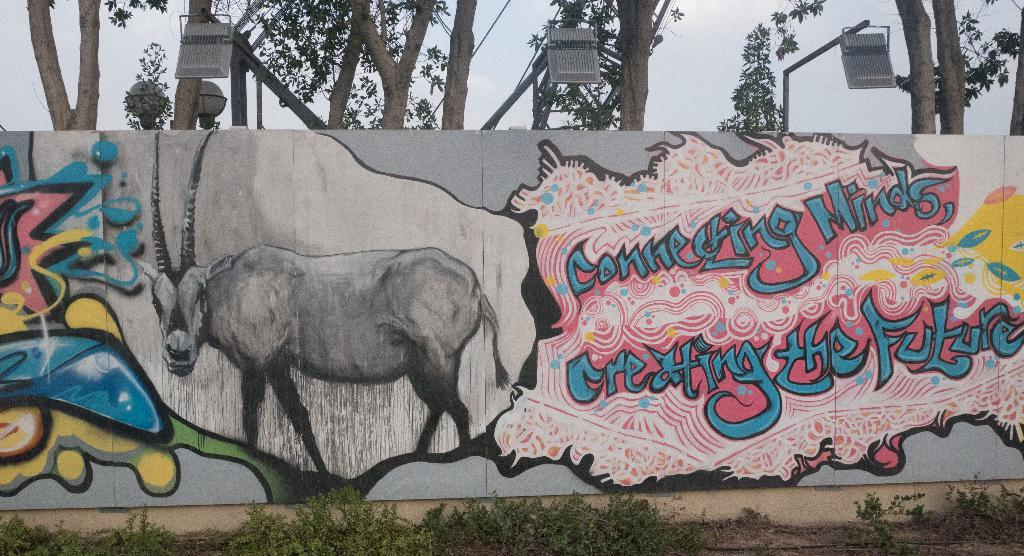What is on the wall in the image? There is a hoarding with text and pictures on the wall. What is on top of the hoarding? There are focus lights on top of the hoarding. What type of vegetation can be seen in the image? There are trees visible in the image. What is in front of the hoarding? There is grass in front of the hoarding. What is the name of the plantation shown in the image? There is no plantation present in the image; it features a hoarding with text and pictures on a wall. How many copies of the hoarding are visible in the image? There is only one hoarding visible in the image. 